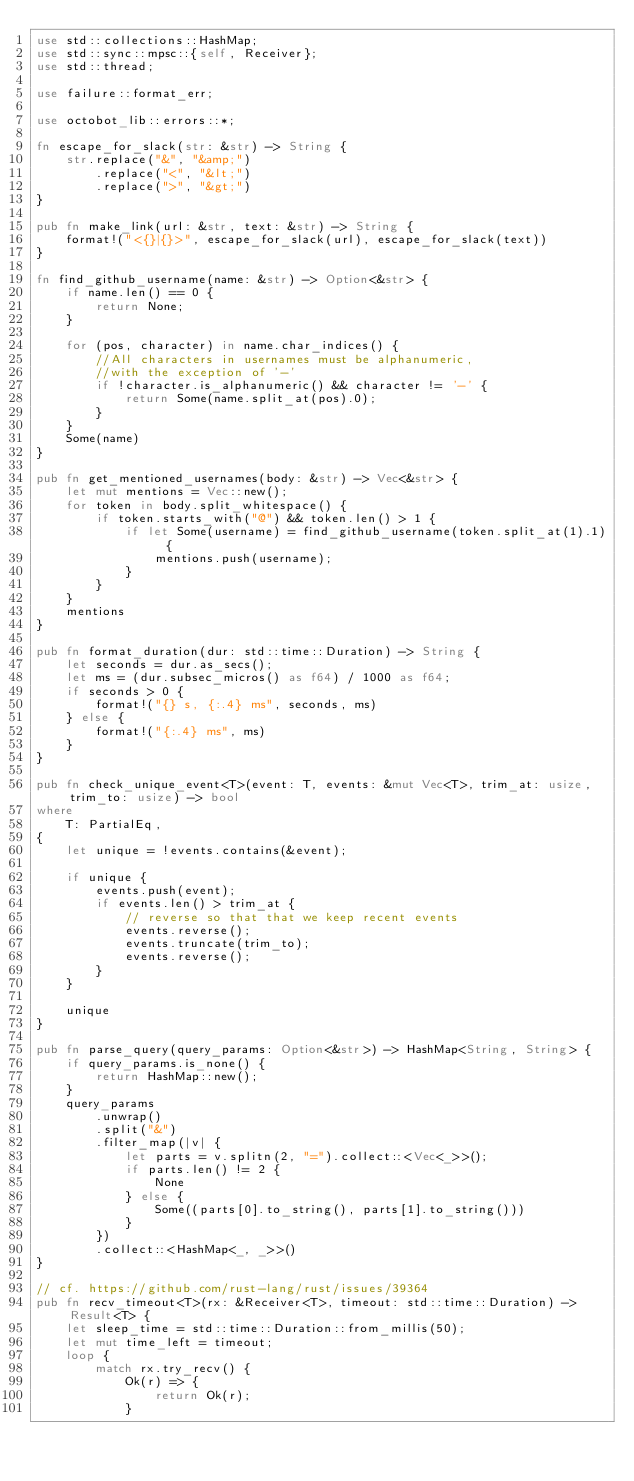Convert code to text. <code><loc_0><loc_0><loc_500><loc_500><_Rust_>use std::collections::HashMap;
use std::sync::mpsc::{self, Receiver};
use std::thread;

use failure::format_err;

use octobot_lib::errors::*;

fn escape_for_slack(str: &str) -> String {
    str.replace("&", "&amp;")
        .replace("<", "&lt;")
        .replace(">", "&gt;")
}

pub fn make_link(url: &str, text: &str) -> String {
    format!("<{}|{}>", escape_for_slack(url), escape_for_slack(text))
}

fn find_github_username(name: &str) -> Option<&str> {
    if name.len() == 0 {
        return None;
    }

    for (pos, character) in name.char_indices() {
        //All characters in usernames must be alphanumeric,
        //with the exception of '-'
        if !character.is_alphanumeric() && character != '-' {
            return Some(name.split_at(pos).0);
        }
    }
    Some(name)
}

pub fn get_mentioned_usernames(body: &str) -> Vec<&str> {
    let mut mentions = Vec::new();
    for token in body.split_whitespace() {
        if token.starts_with("@") && token.len() > 1 {
            if let Some(username) = find_github_username(token.split_at(1).1) {
                mentions.push(username);
            }
        }
    }
    mentions
}

pub fn format_duration(dur: std::time::Duration) -> String {
    let seconds = dur.as_secs();
    let ms = (dur.subsec_micros() as f64) / 1000 as f64;
    if seconds > 0 {
        format!("{} s, {:.4} ms", seconds, ms)
    } else {
        format!("{:.4} ms", ms)
    }
}

pub fn check_unique_event<T>(event: T, events: &mut Vec<T>, trim_at: usize, trim_to: usize) -> bool
where
    T: PartialEq,
{
    let unique = !events.contains(&event);

    if unique {
        events.push(event);
        if events.len() > trim_at {
            // reverse so that that we keep recent events
            events.reverse();
            events.truncate(trim_to);
            events.reverse();
        }
    }

    unique
}

pub fn parse_query(query_params: Option<&str>) -> HashMap<String, String> {
    if query_params.is_none() {
        return HashMap::new();
    }
    query_params
        .unwrap()
        .split("&")
        .filter_map(|v| {
            let parts = v.splitn(2, "=").collect::<Vec<_>>();
            if parts.len() != 2 {
                None
            } else {
                Some((parts[0].to_string(), parts[1].to_string()))
            }
        })
        .collect::<HashMap<_, _>>()
}

// cf. https://github.com/rust-lang/rust/issues/39364
pub fn recv_timeout<T>(rx: &Receiver<T>, timeout: std::time::Duration) -> Result<T> {
    let sleep_time = std::time::Duration::from_millis(50);
    let mut time_left = timeout;
    loop {
        match rx.try_recv() {
            Ok(r) => {
                return Ok(r);
            }</code> 